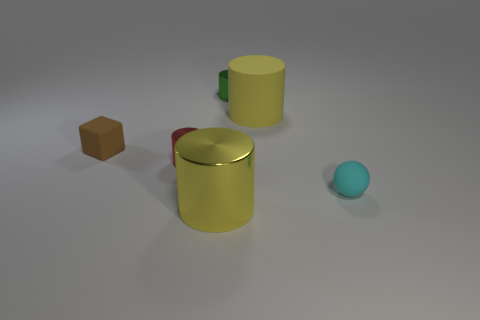Subtract all red shiny cylinders. How many cylinders are left? 3 Add 3 green shiny things. How many objects exist? 9 Subtract all red cylinders. How many cylinders are left? 3 Subtract all cylinders. How many objects are left? 2 Subtract 4 cylinders. How many cylinders are left? 0 Subtract all green blocks. How many yellow cylinders are left? 2 Subtract all big yellow rubber cylinders. Subtract all brown objects. How many objects are left? 4 Add 5 red objects. How many red objects are left? 6 Add 4 tiny red cylinders. How many tiny red cylinders exist? 5 Subtract 0 brown balls. How many objects are left? 6 